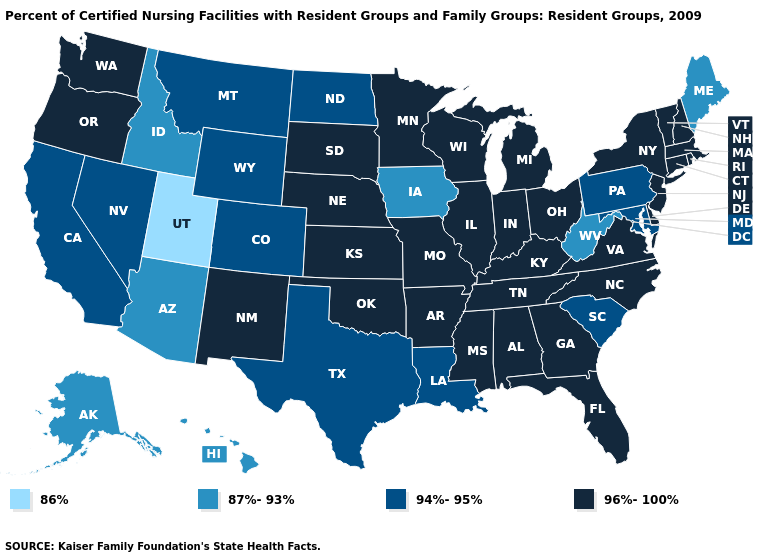Does South Dakota have the lowest value in the USA?
Be succinct. No. Does the first symbol in the legend represent the smallest category?
Write a very short answer. Yes. Does the map have missing data?
Write a very short answer. No. Does Arkansas have the lowest value in the South?
Be succinct. No. Name the states that have a value in the range 86%?
Be succinct. Utah. Which states have the lowest value in the West?
Answer briefly. Utah. Name the states that have a value in the range 96%-100%?
Short answer required. Alabama, Arkansas, Connecticut, Delaware, Florida, Georgia, Illinois, Indiana, Kansas, Kentucky, Massachusetts, Michigan, Minnesota, Mississippi, Missouri, Nebraska, New Hampshire, New Jersey, New Mexico, New York, North Carolina, Ohio, Oklahoma, Oregon, Rhode Island, South Dakota, Tennessee, Vermont, Virginia, Washington, Wisconsin. Name the states that have a value in the range 86%?
Keep it brief. Utah. What is the highest value in states that border Kansas?
Concise answer only. 96%-100%. What is the lowest value in the USA?
Concise answer only. 86%. What is the value of Kentucky?
Quick response, please. 96%-100%. What is the lowest value in the USA?
Short answer required. 86%. Name the states that have a value in the range 86%?
Short answer required. Utah. Which states have the lowest value in the USA?
Write a very short answer. Utah. Among the states that border North Dakota , does Montana have the highest value?
Quick response, please. No. 